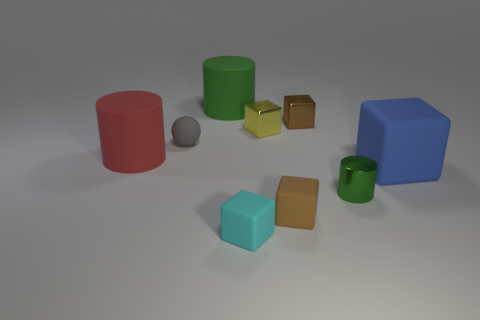What number of other big cubes have the same material as the yellow block?
Your answer should be very brief. 0. There is a big block that is the same material as the tiny gray ball; what color is it?
Ensure brevity in your answer.  Blue. There is a red matte thing; does it have the same size as the green cylinder in front of the large green object?
Provide a succinct answer. No. The tiny brown block in front of the small thing left of the cyan cube left of the blue cube is made of what material?
Offer a terse response. Rubber. What number of objects are small green shiny cylinders or large green rubber objects?
Make the answer very short. 2. There is a tiny block behind the yellow shiny block; does it have the same color as the small matte block that is to the right of the tiny cyan matte object?
Give a very brief answer. Yes. There is a blue rubber thing that is the same size as the green rubber cylinder; what shape is it?
Offer a very short reply. Cube. How many things are either tiny cubes behind the small sphere or brown things that are behind the tiny brown rubber thing?
Give a very brief answer. 2. Is the number of tiny cyan rubber things less than the number of shiny cubes?
Your answer should be compact. Yes. What is the material of the cylinder that is the same size as the green matte thing?
Offer a very short reply. Rubber. 